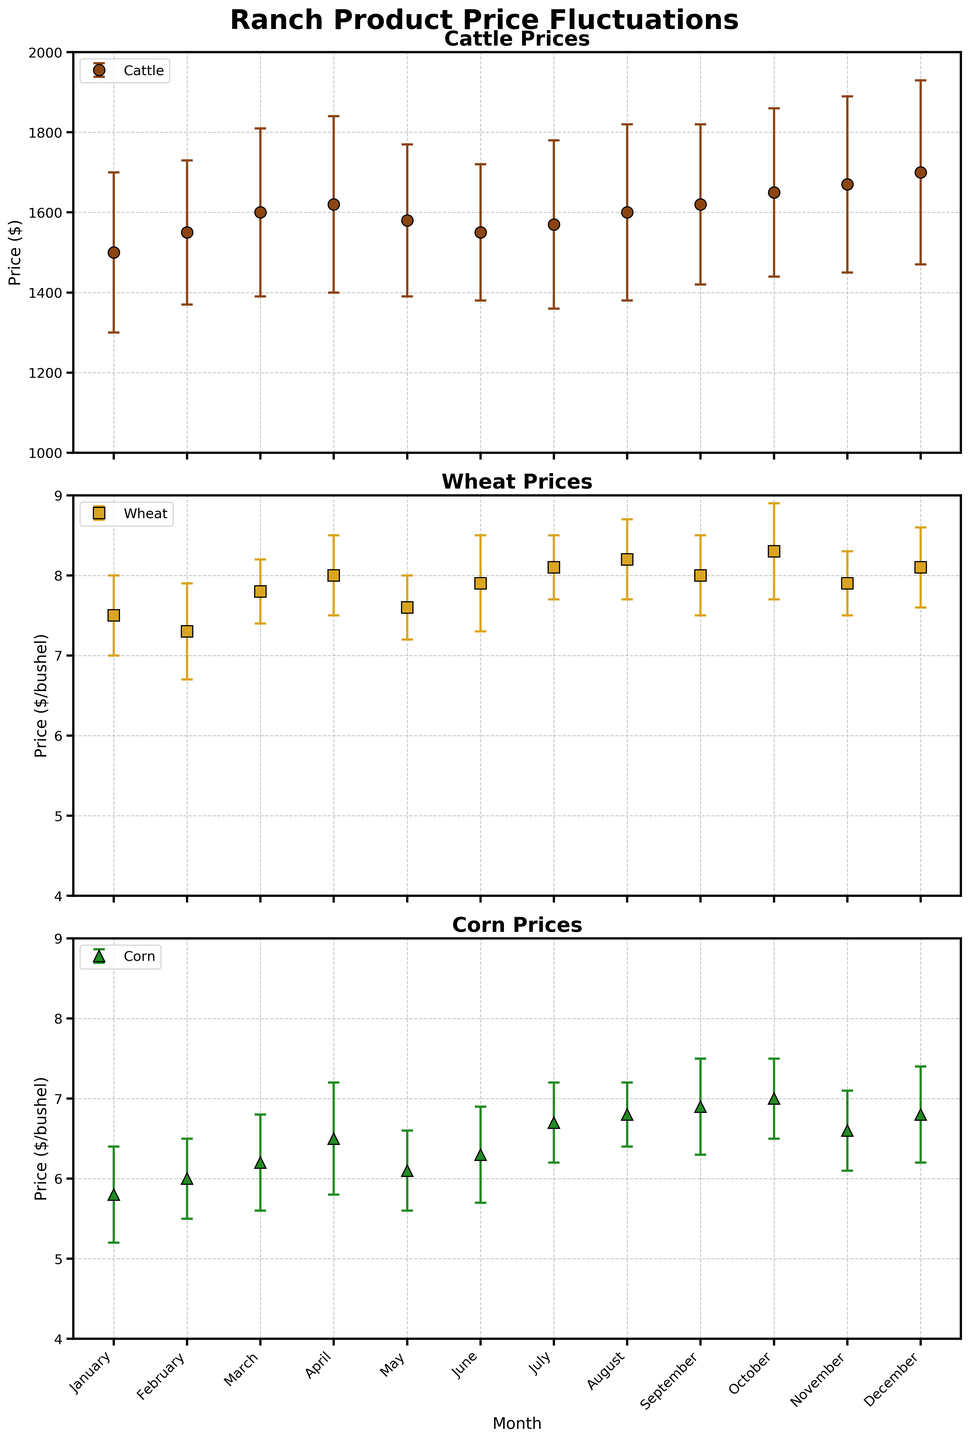Which product showed the highest mean price in December? The subplot for Cattle shows that its mean price in December is 1700, which is higher than the mean prices of Wheat and Corn in December.
Answer: Cattle Which month had the highest mean price for Wheat? The subplot for Wheat indicates that in October, Wheat had the highest mean price of 8.3.
Answer: October What's the average mean price of Cattle over the entire year? Sum the mean prices of Cattle for each month and divide by 12: (1500 + 1550 + 1600 + 1620 + 1580 + 1550 + 1570 + 1600 + 1620 + 1650 + 1670 + 1700) / 12.
Answer: 1,617 In which month does Corn show the lowest mean price? The subplot for Corn reveals that Corn's lowest mean price of 5.8 occurs in January.
Answer: January Which product experienced the most significant price increase from January to December? Comparing subplots: Cattle's price increased from 1500 to 1700 (+200), Wheat from 7.5 to 8.1 (+0.6), and Corn from 5.8 to 6.8 (+1). Cattle had the largest increase.
Answer: Cattle Are there any months where all three products show the same trend (either increasing or decreasing mean prices)? By examining the trend lines on each subplot, October to November shows that all three products have decreasing mean prices: Cattle (1650 to 1670), Wheat (8.1 to 7.9), Corn (7.0 to 6.6).
Answer: Yes Which product had the highest standard deviation in any single month? By observing the error bars, we can see that Cattle in December has the highest standard deviation of 230.
Answer: Cattle in December How does the price trend of Corn in the first half of the year compare to its trend in the second half? From January to June, Corn's price increases (5.8 to 6.3), and from July to December, it continues to increase (6.7 to 6.8) but with a smaller margin.
Answer: Increases in both halves In which month did Wheat have the smallest error bar (indicating the lowest price standard deviation)? The subplot for Wheat reveals that the smallest error bar, indicating the highest standard deviation, is in March with a value of 0.4.
Answer: March 